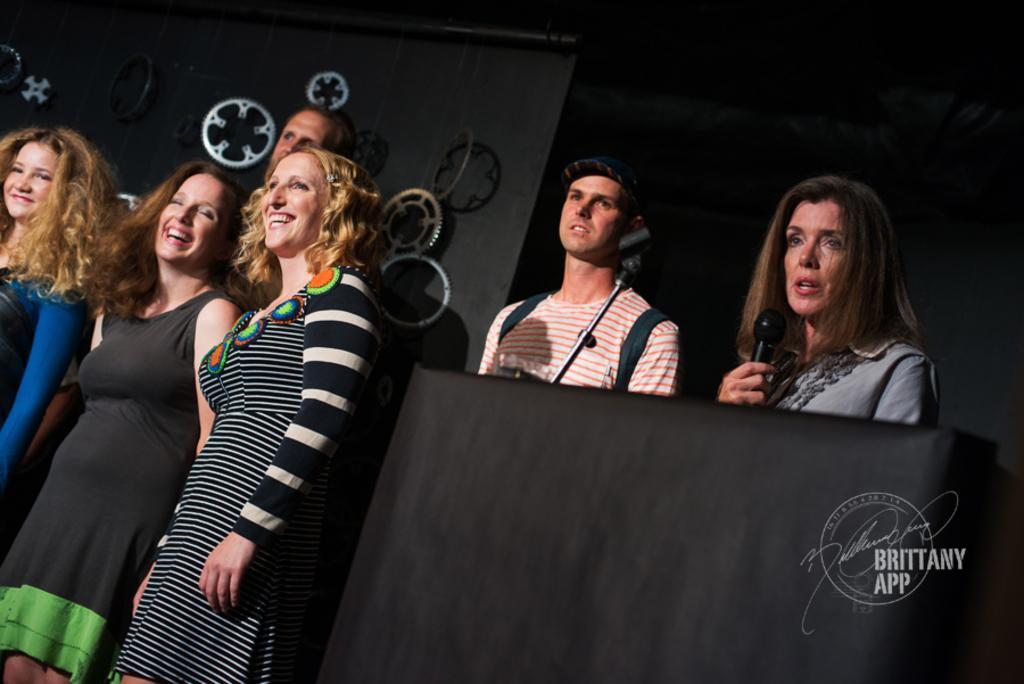Can you describe this image briefly? there is a group of people standing over here in which one woman is talking in a microphone and another persons are laughing. 